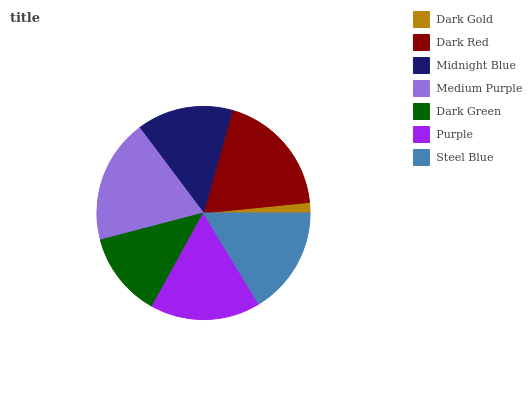Is Dark Gold the minimum?
Answer yes or no. Yes. Is Dark Red the maximum?
Answer yes or no. Yes. Is Midnight Blue the minimum?
Answer yes or no. No. Is Midnight Blue the maximum?
Answer yes or no. No. Is Dark Red greater than Midnight Blue?
Answer yes or no. Yes. Is Midnight Blue less than Dark Red?
Answer yes or no. Yes. Is Midnight Blue greater than Dark Red?
Answer yes or no. No. Is Dark Red less than Midnight Blue?
Answer yes or no. No. Is Steel Blue the high median?
Answer yes or no. Yes. Is Steel Blue the low median?
Answer yes or no. Yes. Is Dark Green the high median?
Answer yes or no. No. Is Dark Gold the low median?
Answer yes or no. No. 